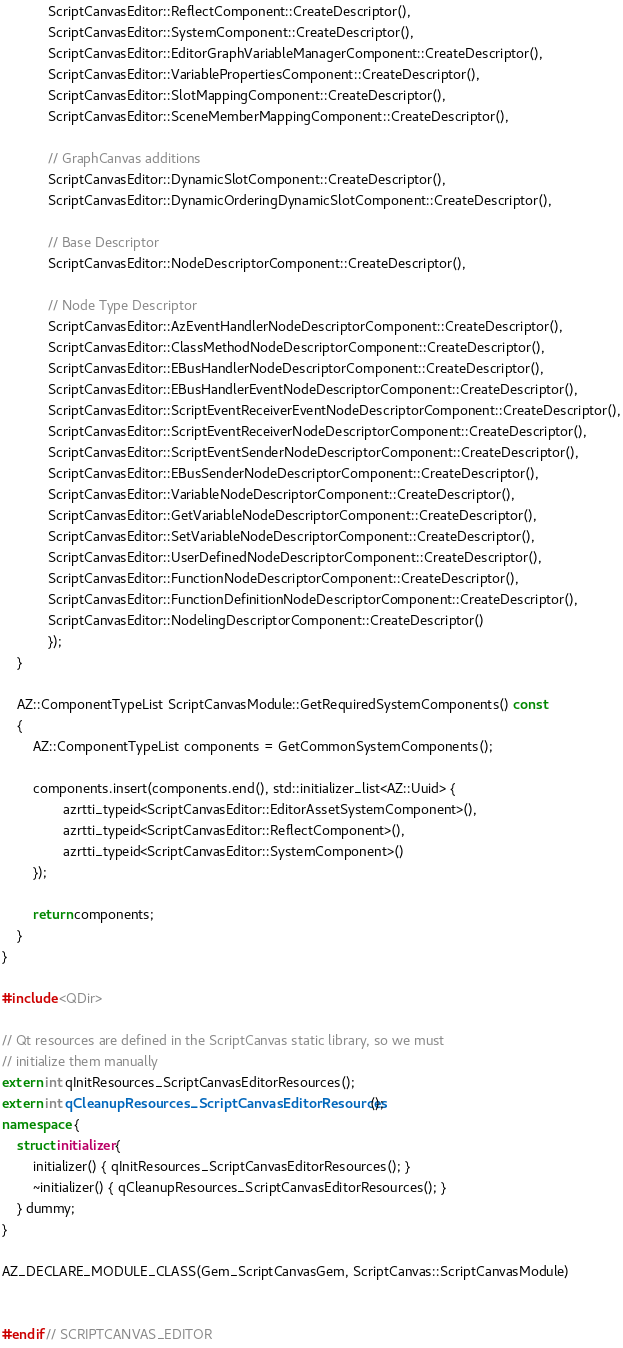Convert code to text. <code><loc_0><loc_0><loc_500><loc_500><_C++_>            ScriptCanvasEditor::ReflectComponent::CreateDescriptor(),
            ScriptCanvasEditor::SystemComponent::CreateDescriptor(),
            ScriptCanvasEditor::EditorGraphVariableManagerComponent::CreateDescriptor(),
            ScriptCanvasEditor::VariablePropertiesComponent::CreateDescriptor(),
            ScriptCanvasEditor::SlotMappingComponent::CreateDescriptor(),
            ScriptCanvasEditor::SceneMemberMappingComponent::CreateDescriptor(),

            // GraphCanvas additions
            ScriptCanvasEditor::DynamicSlotComponent::CreateDescriptor(),
            ScriptCanvasEditor::DynamicOrderingDynamicSlotComponent::CreateDescriptor(),

            // Base Descriptor
            ScriptCanvasEditor::NodeDescriptorComponent::CreateDescriptor(),

            // Node Type Descriptor
            ScriptCanvasEditor::AzEventHandlerNodeDescriptorComponent::CreateDescriptor(),
            ScriptCanvasEditor::ClassMethodNodeDescriptorComponent::CreateDescriptor(),
            ScriptCanvasEditor::EBusHandlerNodeDescriptorComponent::CreateDescriptor(),
            ScriptCanvasEditor::EBusHandlerEventNodeDescriptorComponent::CreateDescriptor(),
            ScriptCanvasEditor::ScriptEventReceiverEventNodeDescriptorComponent::CreateDescriptor(),
            ScriptCanvasEditor::ScriptEventReceiverNodeDescriptorComponent::CreateDescriptor(),
            ScriptCanvasEditor::ScriptEventSenderNodeDescriptorComponent::CreateDescriptor(),
            ScriptCanvasEditor::EBusSenderNodeDescriptorComponent::CreateDescriptor(),
            ScriptCanvasEditor::VariableNodeDescriptorComponent::CreateDescriptor(),
            ScriptCanvasEditor::GetVariableNodeDescriptorComponent::CreateDescriptor(),
            ScriptCanvasEditor::SetVariableNodeDescriptorComponent::CreateDescriptor(),
            ScriptCanvasEditor::UserDefinedNodeDescriptorComponent::CreateDescriptor(),
            ScriptCanvasEditor::FunctionNodeDescriptorComponent::CreateDescriptor(),
            ScriptCanvasEditor::FunctionDefinitionNodeDescriptorComponent::CreateDescriptor(),
            ScriptCanvasEditor::NodelingDescriptorComponent::CreateDescriptor()
            });
    }

    AZ::ComponentTypeList ScriptCanvasModule::GetRequiredSystemComponents() const
    {
        AZ::ComponentTypeList components = GetCommonSystemComponents();

        components.insert(components.end(), std::initializer_list<AZ::Uuid> {
                azrtti_typeid<ScriptCanvasEditor::EditorAssetSystemComponent>(),
                azrtti_typeid<ScriptCanvasEditor::ReflectComponent>(),
                azrtti_typeid<ScriptCanvasEditor::SystemComponent>()
        });

        return components;
    }
}

#include <QDir>

// Qt resources are defined in the ScriptCanvas static library, so we must
// initialize them manually
extern int qInitResources_ScriptCanvasEditorResources();
extern int qCleanupResources_ScriptCanvasEditorResources();
namespace {
    struct initializer {
        initializer() { qInitResources_ScriptCanvasEditorResources(); }
        ~initializer() { qCleanupResources_ScriptCanvasEditorResources(); }
    } dummy;
}

AZ_DECLARE_MODULE_CLASS(Gem_ScriptCanvasGem, ScriptCanvas::ScriptCanvasModule)


#endif // SCRIPTCANVAS_EDITOR
</code> 